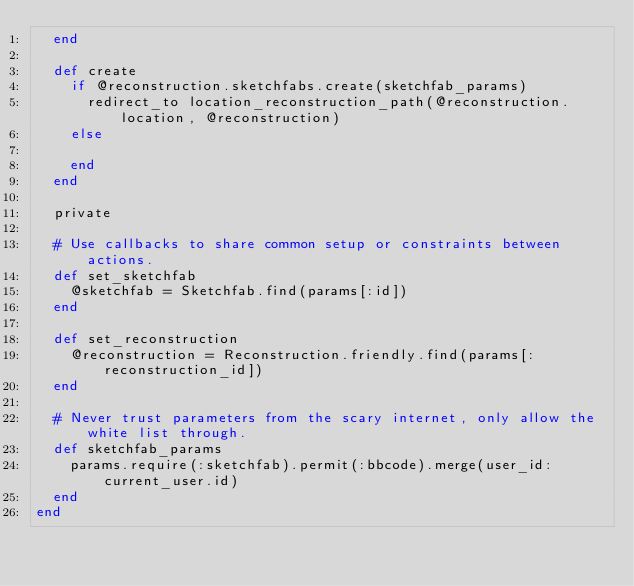Convert code to text. <code><loc_0><loc_0><loc_500><loc_500><_Ruby_>  end

  def create
    if @reconstruction.sketchfabs.create(sketchfab_params)
      redirect_to location_reconstruction_path(@reconstruction.location, @reconstruction)
    else

    end
  end

  private

  # Use callbacks to share common setup or constraints between actions.
  def set_sketchfab
    @sketchfab = Sketchfab.find(params[:id])
  end

  def set_reconstruction
    @reconstruction = Reconstruction.friendly.find(params[:reconstruction_id])
  end

  # Never trust parameters from the scary internet, only allow the white list through.
  def sketchfab_params
    params.require(:sketchfab).permit(:bbcode).merge(user_id: current_user.id)
  end
end</code> 